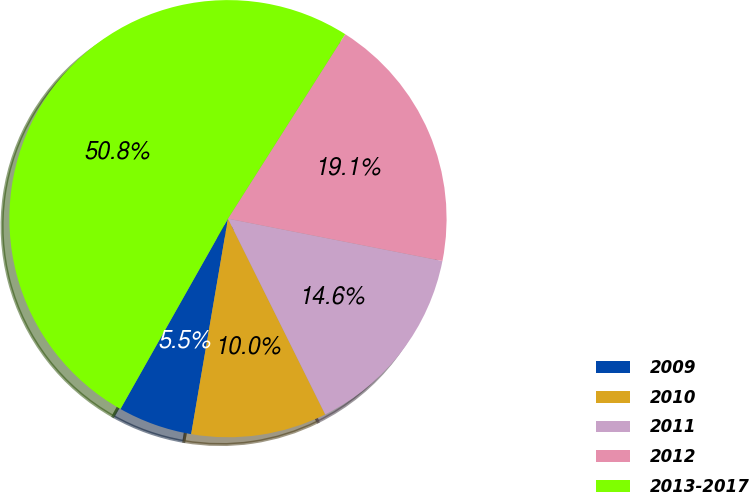<chart> <loc_0><loc_0><loc_500><loc_500><pie_chart><fcel>2009<fcel>2010<fcel>2011<fcel>2012<fcel>2013-2017<nl><fcel>5.49%<fcel>10.03%<fcel>14.56%<fcel>19.09%<fcel>50.82%<nl></chart> 